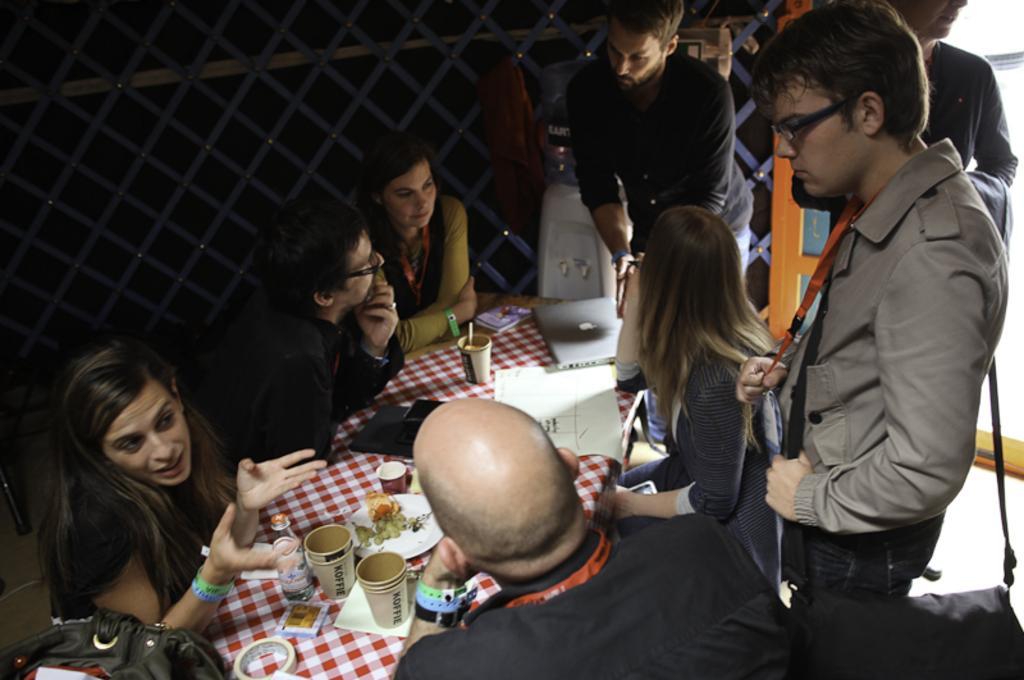How would you summarize this image in a sentence or two? In this picture we can see some people sitting on chairs and some people standing. In front of the people, there is a table which is covered by a cloth. On the table, there are cups, a bottle, laptop and some objects. Behind the people, there are some other objects and a grille. 